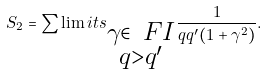<formula> <loc_0><loc_0><loc_500><loc_500>S _ { 2 } = \sum \lim i t s _ { \substack { \gamma \in \ F I \\ q > q ^ { \prime } } } \frac { 1 } { q q ^ { \prime } ( 1 + \gamma ^ { 2 } ) } .</formula> 